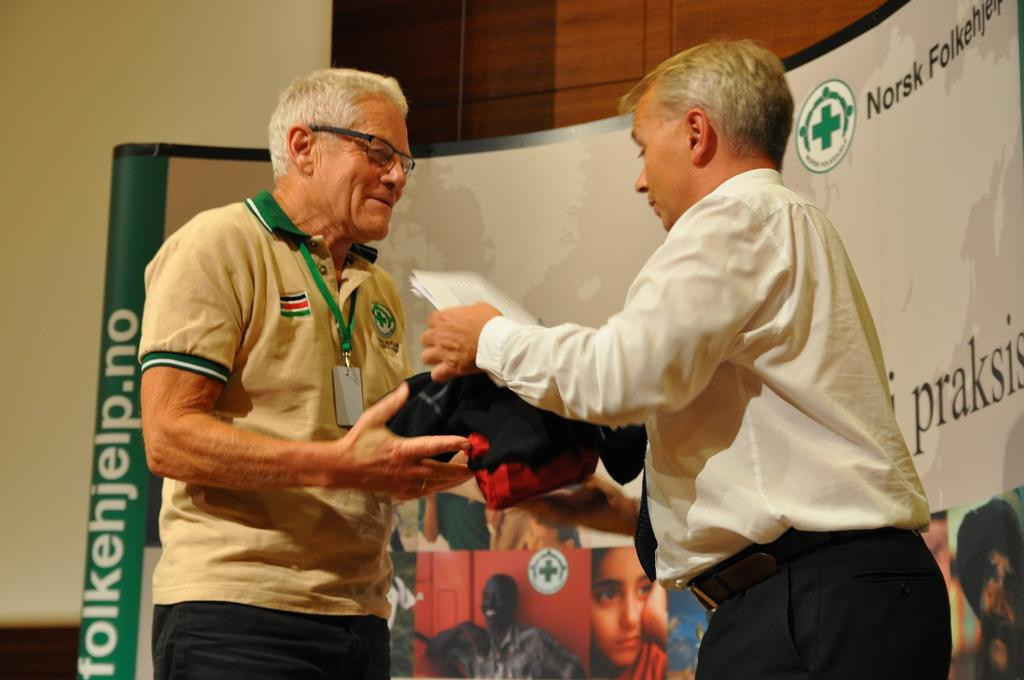How many people are in the image? There are two persons in the image. What are the persons doing in the image? The persons are standing. What are the persons holding in the image? The persons are holding objects. What can be seen in the background of the image? There is a board and a wall in the background of the image. What type of finger can be seen holding the kettle in the image? There is no kettle or finger present in the image. 